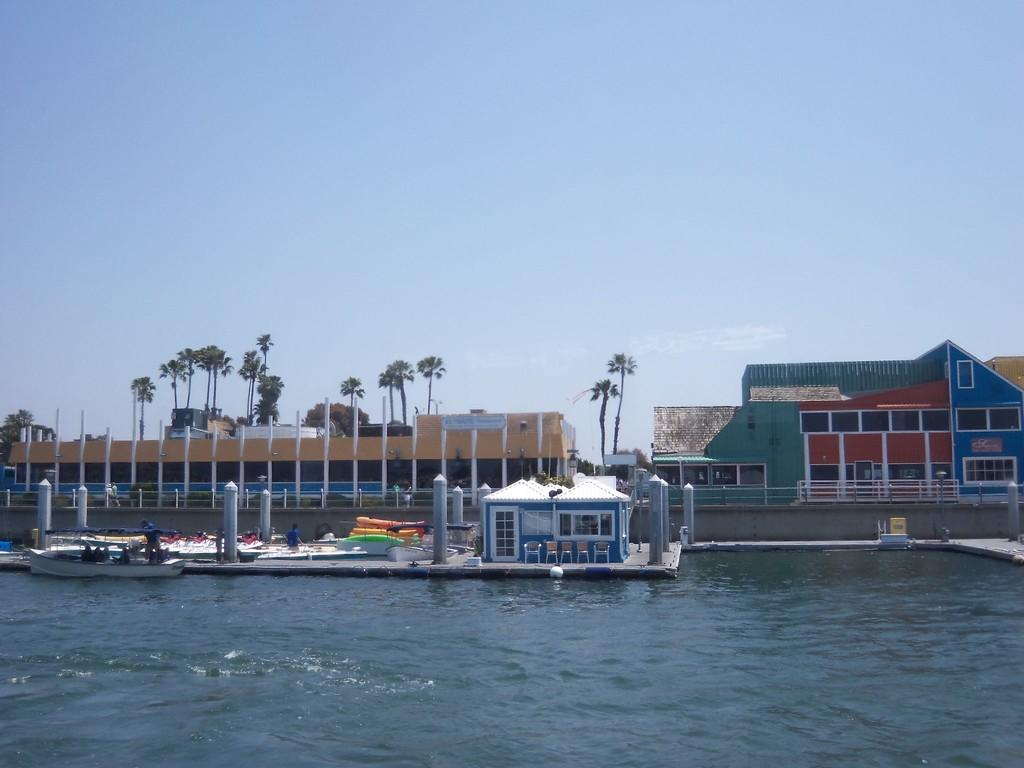What is located in the front of the image? In the front of the image, there is water, shelters, trees, railings, plants, boats, and pillars. What type of structures are the shelters? The shelters in the front of the image are not described in detail, but they are visible. What can be seen in the background of the image? The sky is visible in the background of the image. How many objects are present in the front of the image? There are multiple objects present in the front of the image, including water, shelters, trees, railings, plants, boats, and pillars. What type of nerve can be seen in the image? There is no nerve present in the image. What line is visible in the image? The image does not depict a specific line. 